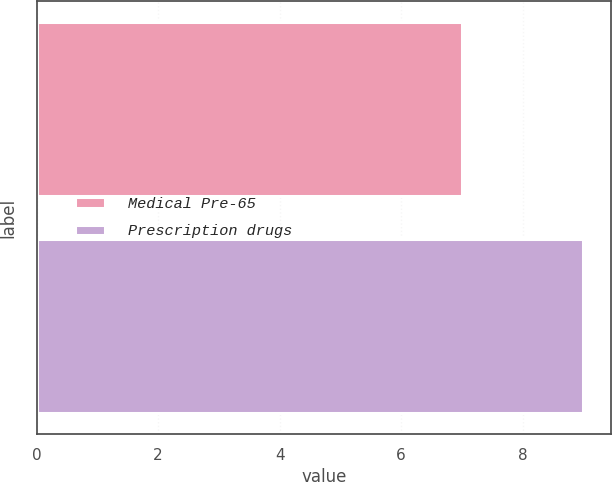Convert chart to OTSL. <chart><loc_0><loc_0><loc_500><loc_500><bar_chart><fcel>Medical Pre-65<fcel>Prescription drugs<nl><fcel>7<fcel>9<nl></chart> 